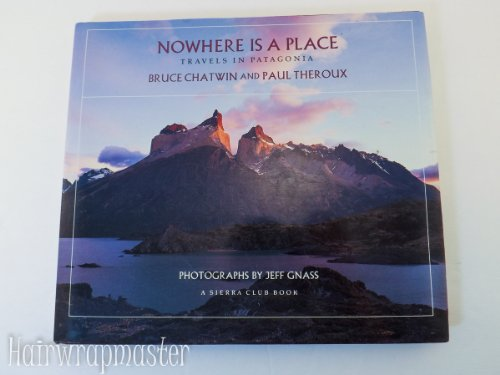Who wrote this book? The book 'Nowhere Is a Place: Travels in Patagonia' was co-authored by Bruce Chatwin and Paul Theroux, known for their engaging travel narratives. 